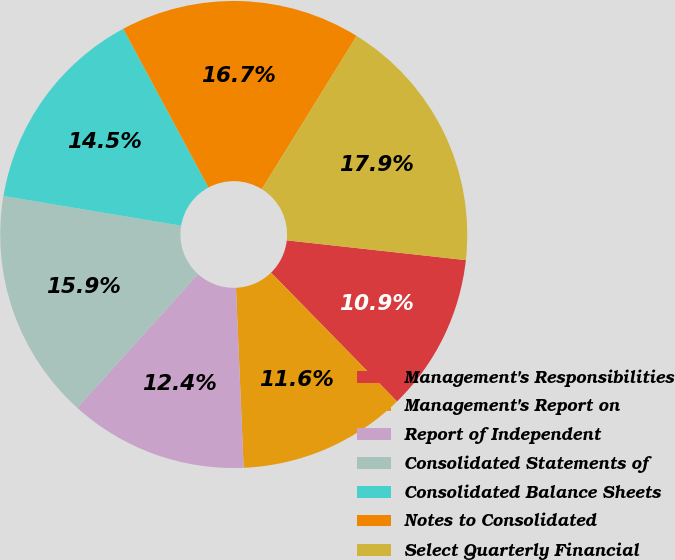Convert chart to OTSL. <chart><loc_0><loc_0><loc_500><loc_500><pie_chart><fcel>Management's Responsibilities<fcel>Management's Report on<fcel>Report of Independent<fcel>Consolidated Statements of<fcel>Consolidated Balance Sheets<fcel>Notes to Consolidated<fcel>Select Quarterly Financial<nl><fcel>10.93%<fcel>11.65%<fcel>12.36%<fcel>15.95%<fcel>14.52%<fcel>16.67%<fcel>17.93%<nl></chart> 